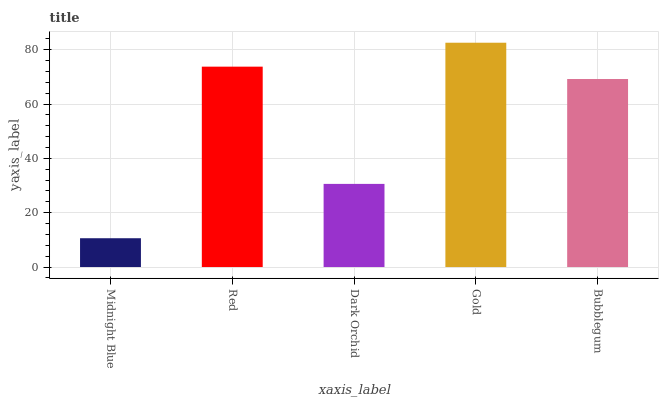Is Midnight Blue the minimum?
Answer yes or no. Yes. Is Gold the maximum?
Answer yes or no. Yes. Is Red the minimum?
Answer yes or no. No. Is Red the maximum?
Answer yes or no. No. Is Red greater than Midnight Blue?
Answer yes or no. Yes. Is Midnight Blue less than Red?
Answer yes or no. Yes. Is Midnight Blue greater than Red?
Answer yes or no. No. Is Red less than Midnight Blue?
Answer yes or no. No. Is Bubblegum the high median?
Answer yes or no. Yes. Is Bubblegum the low median?
Answer yes or no. Yes. Is Gold the high median?
Answer yes or no. No. Is Midnight Blue the low median?
Answer yes or no. No. 